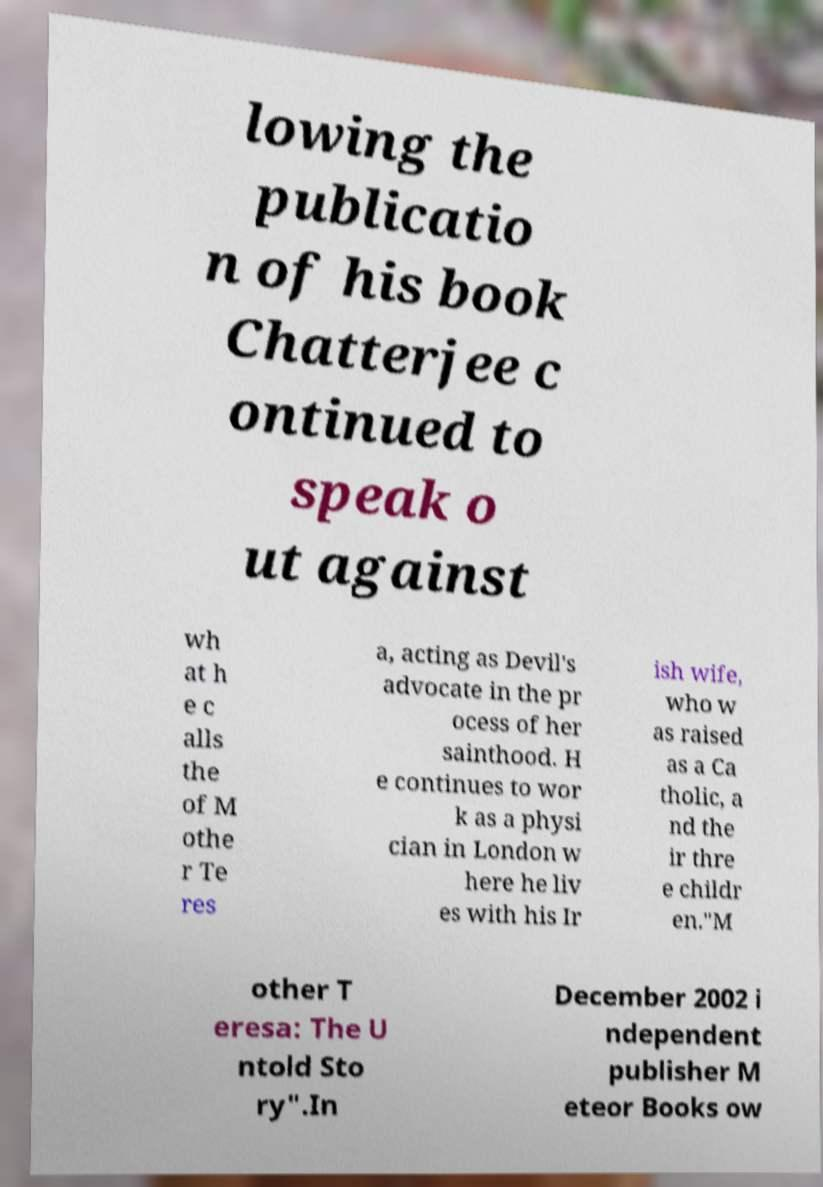Could you assist in decoding the text presented in this image and type it out clearly? lowing the publicatio n of his book Chatterjee c ontinued to speak o ut against wh at h e c alls the of M othe r Te res a, acting as Devil's advocate in the pr ocess of her sainthood. H e continues to wor k as a physi cian in London w here he liv es with his Ir ish wife, who w as raised as a Ca tholic, a nd the ir thre e childr en."M other T eresa: The U ntold Sto ry".In December 2002 i ndependent publisher M eteor Books ow 